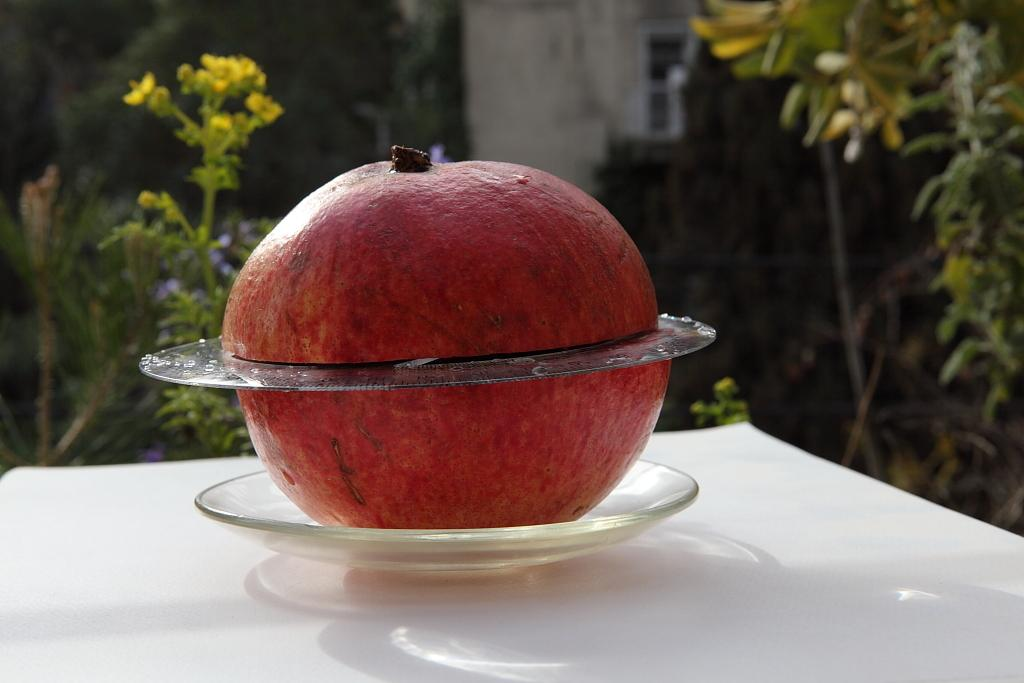What type of fruit is in the image? There is a red pomegranate in the image. How is the pomegranate displayed? The pomegranate is in a small transparent plate. What is the surface beneath the plate? The plate is placed on a wooden table top. What can be seen in the background of the image? There are plants visible in the background of the image. What type of metal is the fire burning on in the image? There is no fire or metal present in the image; it features a red pomegranate in a small transparent plate on a wooden table top, with plants visible in the background. 